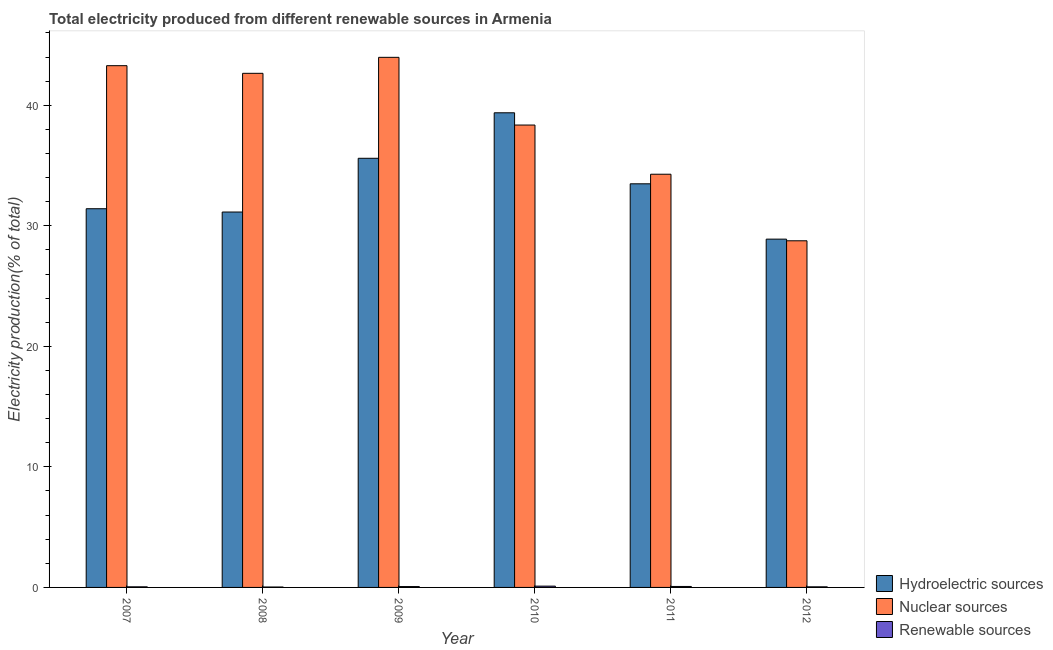How many groups of bars are there?
Ensure brevity in your answer.  6. Are the number of bars per tick equal to the number of legend labels?
Offer a terse response. Yes. What is the percentage of electricity produced by hydroelectric sources in 2011?
Your response must be concise. 33.49. Across all years, what is the maximum percentage of electricity produced by nuclear sources?
Keep it short and to the point. 43.98. Across all years, what is the minimum percentage of electricity produced by nuclear sources?
Offer a terse response. 28.76. What is the total percentage of electricity produced by nuclear sources in the graph?
Your answer should be very brief. 231.31. What is the difference between the percentage of electricity produced by hydroelectric sources in 2008 and that in 2009?
Your answer should be compact. -4.46. What is the difference between the percentage of electricity produced by nuclear sources in 2010 and the percentage of electricity produced by hydroelectric sources in 2008?
Offer a terse response. -4.29. What is the average percentage of electricity produced by nuclear sources per year?
Keep it short and to the point. 38.55. What is the ratio of the percentage of electricity produced by nuclear sources in 2010 to that in 2011?
Offer a terse response. 1.12. Is the difference between the percentage of electricity produced by hydroelectric sources in 2008 and 2011 greater than the difference between the percentage of electricity produced by renewable sources in 2008 and 2011?
Give a very brief answer. No. What is the difference between the highest and the second highest percentage of electricity produced by hydroelectric sources?
Give a very brief answer. 3.78. What is the difference between the highest and the lowest percentage of electricity produced by hydroelectric sources?
Offer a very short reply. 10.48. In how many years, is the percentage of electricity produced by nuclear sources greater than the average percentage of electricity produced by nuclear sources taken over all years?
Your response must be concise. 3. Is the sum of the percentage of electricity produced by hydroelectric sources in 2007 and 2011 greater than the maximum percentage of electricity produced by renewable sources across all years?
Give a very brief answer. Yes. What does the 3rd bar from the left in 2010 represents?
Keep it short and to the point. Renewable sources. What does the 2nd bar from the right in 2007 represents?
Provide a short and direct response. Nuclear sources. Is it the case that in every year, the sum of the percentage of electricity produced by hydroelectric sources and percentage of electricity produced by nuclear sources is greater than the percentage of electricity produced by renewable sources?
Keep it short and to the point. Yes. Are all the bars in the graph horizontal?
Your answer should be very brief. No. How many years are there in the graph?
Offer a terse response. 6. What is the difference between two consecutive major ticks on the Y-axis?
Offer a very short reply. 10. Does the graph contain grids?
Provide a succinct answer. No. Where does the legend appear in the graph?
Your response must be concise. Bottom right. How many legend labels are there?
Give a very brief answer. 3. What is the title of the graph?
Offer a terse response. Total electricity produced from different renewable sources in Armenia. What is the label or title of the Y-axis?
Provide a short and direct response. Electricity production(% of total). What is the Electricity production(% of total) in Hydroelectric sources in 2007?
Your response must be concise. 31.42. What is the Electricity production(% of total) in Nuclear sources in 2007?
Offer a terse response. 43.29. What is the Electricity production(% of total) of Renewable sources in 2007?
Provide a succinct answer. 0.05. What is the Electricity production(% of total) in Hydroelectric sources in 2008?
Make the answer very short. 31.14. What is the Electricity production(% of total) of Nuclear sources in 2008?
Ensure brevity in your answer.  42.65. What is the Electricity production(% of total) in Renewable sources in 2008?
Your response must be concise. 0.03. What is the Electricity production(% of total) of Hydroelectric sources in 2009?
Provide a short and direct response. 35.6. What is the Electricity production(% of total) in Nuclear sources in 2009?
Your answer should be very brief. 43.98. What is the Electricity production(% of total) in Renewable sources in 2009?
Offer a terse response. 0.07. What is the Electricity production(% of total) of Hydroelectric sources in 2010?
Offer a very short reply. 39.38. What is the Electricity production(% of total) in Nuclear sources in 2010?
Provide a short and direct response. 38.36. What is the Electricity production(% of total) in Renewable sources in 2010?
Your answer should be very brief. 0.11. What is the Electricity production(% of total) of Hydroelectric sources in 2011?
Your answer should be very brief. 33.49. What is the Electricity production(% of total) of Nuclear sources in 2011?
Provide a succinct answer. 34.28. What is the Electricity production(% of total) in Renewable sources in 2011?
Give a very brief answer. 0.08. What is the Electricity production(% of total) of Hydroelectric sources in 2012?
Keep it short and to the point. 28.89. What is the Electricity production(% of total) in Nuclear sources in 2012?
Provide a succinct answer. 28.76. What is the Electricity production(% of total) in Renewable sources in 2012?
Offer a very short reply. 0.05. Across all years, what is the maximum Electricity production(% of total) of Hydroelectric sources?
Ensure brevity in your answer.  39.38. Across all years, what is the maximum Electricity production(% of total) of Nuclear sources?
Keep it short and to the point. 43.98. Across all years, what is the maximum Electricity production(% of total) in Renewable sources?
Provide a short and direct response. 0.11. Across all years, what is the minimum Electricity production(% of total) of Hydroelectric sources?
Provide a succinct answer. 28.89. Across all years, what is the minimum Electricity production(% of total) in Nuclear sources?
Offer a very short reply. 28.76. Across all years, what is the minimum Electricity production(% of total) of Renewable sources?
Offer a very short reply. 0.03. What is the total Electricity production(% of total) of Hydroelectric sources in the graph?
Make the answer very short. 199.92. What is the total Electricity production(% of total) of Nuclear sources in the graph?
Provide a short and direct response. 231.31. What is the total Electricity production(% of total) in Renewable sources in the graph?
Provide a succinct answer. 0.39. What is the difference between the Electricity production(% of total) of Hydroelectric sources in 2007 and that in 2008?
Ensure brevity in your answer.  0.27. What is the difference between the Electricity production(% of total) in Nuclear sources in 2007 and that in 2008?
Provide a succinct answer. 0.63. What is the difference between the Electricity production(% of total) of Renewable sources in 2007 and that in 2008?
Make the answer very short. 0.02. What is the difference between the Electricity production(% of total) in Hydroelectric sources in 2007 and that in 2009?
Keep it short and to the point. -4.18. What is the difference between the Electricity production(% of total) of Nuclear sources in 2007 and that in 2009?
Provide a short and direct response. -0.69. What is the difference between the Electricity production(% of total) of Renewable sources in 2007 and that in 2009?
Give a very brief answer. -0.02. What is the difference between the Electricity production(% of total) in Hydroelectric sources in 2007 and that in 2010?
Your response must be concise. -7.96. What is the difference between the Electricity production(% of total) in Nuclear sources in 2007 and that in 2010?
Keep it short and to the point. 4.93. What is the difference between the Electricity production(% of total) of Renewable sources in 2007 and that in 2010?
Offer a terse response. -0.06. What is the difference between the Electricity production(% of total) of Hydroelectric sources in 2007 and that in 2011?
Offer a terse response. -2.07. What is the difference between the Electricity production(% of total) in Nuclear sources in 2007 and that in 2011?
Provide a short and direct response. 9.01. What is the difference between the Electricity production(% of total) in Renewable sources in 2007 and that in 2011?
Offer a very short reply. -0.03. What is the difference between the Electricity production(% of total) of Hydroelectric sources in 2007 and that in 2012?
Offer a very short reply. 2.52. What is the difference between the Electricity production(% of total) in Nuclear sources in 2007 and that in 2012?
Provide a succinct answer. 14.53. What is the difference between the Electricity production(% of total) in Renewable sources in 2007 and that in 2012?
Provide a succinct answer. 0. What is the difference between the Electricity production(% of total) of Hydroelectric sources in 2008 and that in 2009?
Make the answer very short. -4.46. What is the difference between the Electricity production(% of total) in Nuclear sources in 2008 and that in 2009?
Provide a succinct answer. -1.33. What is the difference between the Electricity production(% of total) of Renewable sources in 2008 and that in 2009?
Make the answer very short. -0.04. What is the difference between the Electricity production(% of total) of Hydroelectric sources in 2008 and that in 2010?
Make the answer very short. -8.23. What is the difference between the Electricity production(% of total) in Nuclear sources in 2008 and that in 2010?
Provide a short and direct response. 4.29. What is the difference between the Electricity production(% of total) of Renewable sources in 2008 and that in 2010?
Your response must be concise. -0.07. What is the difference between the Electricity production(% of total) of Hydroelectric sources in 2008 and that in 2011?
Your answer should be compact. -2.34. What is the difference between the Electricity production(% of total) of Nuclear sources in 2008 and that in 2011?
Ensure brevity in your answer.  8.37. What is the difference between the Electricity production(% of total) in Renewable sources in 2008 and that in 2011?
Ensure brevity in your answer.  -0.05. What is the difference between the Electricity production(% of total) of Hydroelectric sources in 2008 and that in 2012?
Your answer should be compact. 2.25. What is the difference between the Electricity production(% of total) in Nuclear sources in 2008 and that in 2012?
Provide a succinct answer. 13.89. What is the difference between the Electricity production(% of total) of Renewable sources in 2008 and that in 2012?
Provide a short and direct response. -0.02. What is the difference between the Electricity production(% of total) in Hydroelectric sources in 2009 and that in 2010?
Ensure brevity in your answer.  -3.78. What is the difference between the Electricity production(% of total) in Nuclear sources in 2009 and that in 2010?
Keep it short and to the point. 5.62. What is the difference between the Electricity production(% of total) in Renewable sources in 2009 and that in 2010?
Your answer should be very brief. -0.04. What is the difference between the Electricity production(% of total) in Hydroelectric sources in 2009 and that in 2011?
Your answer should be very brief. 2.12. What is the difference between the Electricity production(% of total) in Nuclear sources in 2009 and that in 2011?
Your answer should be compact. 9.7. What is the difference between the Electricity production(% of total) in Renewable sources in 2009 and that in 2011?
Ensure brevity in your answer.  -0.01. What is the difference between the Electricity production(% of total) of Hydroelectric sources in 2009 and that in 2012?
Offer a very short reply. 6.71. What is the difference between the Electricity production(% of total) of Nuclear sources in 2009 and that in 2012?
Make the answer very short. 15.22. What is the difference between the Electricity production(% of total) of Renewable sources in 2009 and that in 2012?
Make the answer very short. 0.02. What is the difference between the Electricity production(% of total) of Hydroelectric sources in 2010 and that in 2011?
Offer a terse response. 5.89. What is the difference between the Electricity production(% of total) of Nuclear sources in 2010 and that in 2011?
Your response must be concise. 4.08. What is the difference between the Electricity production(% of total) in Renewable sources in 2010 and that in 2011?
Give a very brief answer. 0.03. What is the difference between the Electricity production(% of total) in Hydroelectric sources in 2010 and that in 2012?
Make the answer very short. 10.48. What is the difference between the Electricity production(% of total) in Nuclear sources in 2010 and that in 2012?
Provide a short and direct response. 9.6. What is the difference between the Electricity production(% of total) in Renewable sources in 2010 and that in 2012?
Offer a very short reply. 0.06. What is the difference between the Electricity production(% of total) of Hydroelectric sources in 2011 and that in 2012?
Make the answer very short. 4.59. What is the difference between the Electricity production(% of total) in Nuclear sources in 2011 and that in 2012?
Offer a very short reply. 5.52. What is the difference between the Electricity production(% of total) of Renewable sources in 2011 and that in 2012?
Make the answer very short. 0.03. What is the difference between the Electricity production(% of total) in Hydroelectric sources in 2007 and the Electricity production(% of total) in Nuclear sources in 2008?
Offer a very short reply. -11.23. What is the difference between the Electricity production(% of total) in Hydroelectric sources in 2007 and the Electricity production(% of total) in Renewable sources in 2008?
Give a very brief answer. 31.38. What is the difference between the Electricity production(% of total) in Nuclear sources in 2007 and the Electricity production(% of total) in Renewable sources in 2008?
Your answer should be very brief. 43.25. What is the difference between the Electricity production(% of total) in Hydroelectric sources in 2007 and the Electricity production(% of total) in Nuclear sources in 2009?
Provide a succinct answer. -12.56. What is the difference between the Electricity production(% of total) of Hydroelectric sources in 2007 and the Electricity production(% of total) of Renewable sources in 2009?
Your response must be concise. 31.35. What is the difference between the Electricity production(% of total) of Nuclear sources in 2007 and the Electricity production(% of total) of Renewable sources in 2009?
Make the answer very short. 43.22. What is the difference between the Electricity production(% of total) in Hydroelectric sources in 2007 and the Electricity production(% of total) in Nuclear sources in 2010?
Your answer should be compact. -6.94. What is the difference between the Electricity production(% of total) of Hydroelectric sources in 2007 and the Electricity production(% of total) of Renewable sources in 2010?
Your answer should be very brief. 31.31. What is the difference between the Electricity production(% of total) of Nuclear sources in 2007 and the Electricity production(% of total) of Renewable sources in 2010?
Your response must be concise. 43.18. What is the difference between the Electricity production(% of total) in Hydroelectric sources in 2007 and the Electricity production(% of total) in Nuclear sources in 2011?
Ensure brevity in your answer.  -2.86. What is the difference between the Electricity production(% of total) in Hydroelectric sources in 2007 and the Electricity production(% of total) in Renewable sources in 2011?
Your answer should be compact. 31.34. What is the difference between the Electricity production(% of total) of Nuclear sources in 2007 and the Electricity production(% of total) of Renewable sources in 2011?
Offer a very short reply. 43.21. What is the difference between the Electricity production(% of total) in Hydroelectric sources in 2007 and the Electricity production(% of total) in Nuclear sources in 2012?
Give a very brief answer. 2.66. What is the difference between the Electricity production(% of total) of Hydroelectric sources in 2007 and the Electricity production(% of total) of Renewable sources in 2012?
Your response must be concise. 31.37. What is the difference between the Electricity production(% of total) in Nuclear sources in 2007 and the Electricity production(% of total) in Renewable sources in 2012?
Provide a succinct answer. 43.24. What is the difference between the Electricity production(% of total) in Hydroelectric sources in 2008 and the Electricity production(% of total) in Nuclear sources in 2009?
Give a very brief answer. -12.83. What is the difference between the Electricity production(% of total) of Hydroelectric sources in 2008 and the Electricity production(% of total) of Renewable sources in 2009?
Provide a short and direct response. 31.07. What is the difference between the Electricity production(% of total) in Nuclear sources in 2008 and the Electricity production(% of total) in Renewable sources in 2009?
Provide a short and direct response. 42.58. What is the difference between the Electricity production(% of total) of Hydroelectric sources in 2008 and the Electricity production(% of total) of Nuclear sources in 2010?
Provide a succinct answer. -7.22. What is the difference between the Electricity production(% of total) in Hydroelectric sources in 2008 and the Electricity production(% of total) in Renewable sources in 2010?
Make the answer very short. 31.04. What is the difference between the Electricity production(% of total) of Nuclear sources in 2008 and the Electricity production(% of total) of Renewable sources in 2010?
Offer a terse response. 42.54. What is the difference between the Electricity production(% of total) in Hydroelectric sources in 2008 and the Electricity production(% of total) in Nuclear sources in 2011?
Keep it short and to the point. -3.14. What is the difference between the Electricity production(% of total) in Hydroelectric sources in 2008 and the Electricity production(% of total) in Renewable sources in 2011?
Make the answer very short. 31.06. What is the difference between the Electricity production(% of total) of Nuclear sources in 2008 and the Electricity production(% of total) of Renewable sources in 2011?
Provide a succinct answer. 42.57. What is the difference between the Electricity production(% of total) in Hydroelectric sources in 2008 and the Electricity production(% of total) in Nuclear sources in 2012?
Make the answer very short. 2.39. What is the difference between the Electricity production(% of total) of Hydroelectric sources in 2008 and the Electricity production(% of total) of Renewable sources in 2012?
Keep it short and to the point. 31.09. What is the difference between the Electricity production(% of total) in Nuclear sources in 2008 and the Electricity production(% of total) in Renewable sources in 2012?
Provide a succinct answer. 42.6. What is the difference between the Electricity production(% of total) of Hydroelectric sources in 2009 and the Electricity production(% of total) of Nuclear sources in 2010?
Your answer should be very brief. -2.76. What is the difference between the Electricity production(% of total) of Hydroelectric sources in 2009 and the Electricity production(% of total) of Renewable sources in 2010?
Offer a very short reply. 35.49. What is the difference between the Electricity production(% of total) of Nuclear sources in 2009 and the Electricity production(% of total) of Renewable sources in 2010?
Offer a very short reply. 43.87. What is the difference between the Electricity production(% of total) of Hydroelectric sources in 2009 and the Electricity production(% of total) of Nuclear sources in 2011?
Offer a very short reply. 1.32. What is the difference between the Electricity production(% of total) in Hydroelectric sources in 2009 and the Electricity production(% of total) in Renewable sources in 2011?
Your answer should be very brief. 35.52. What is the difference between the Electricity production(% of total) of Nuclear sources in 2009 and the Electricity production(% of total) of Renewable sources in 2011?
Provide a short and direct response. 43.9. What is the difference between the Electricity production(% of total) of Hydroelectric sources in 2009 and the Electricity production(% of total) of Nuclear sources in 2012?
Ensure brevity in your answer.  6.84. What is the difference between the Electricity production(% of total) in Hydroelectric sources in 2009 and the Electricity production(% of total) in Renewable sources in 2012?
Your response must be concise. 35.55. What is the difference between the Electricity production(% of total) of Nuclear sources in 2009 and the Electricity production(% of total) of Renewable sources in 2012?
Make the answer very short. 43.93. What is the difference between the Electricity production(% of total) in Hydroelectric sources in 2010 and the Electricity production(% of total) in Nuclear sources in 2011?
Ensure brevity in your answer.  5.1. What is the difference between the Electricity production(% of total) in Hydroelectric sources in 2010 and the Electricity production(% of total) in Renewable sources in 2011?
Your response must be concise. 39.3. What is the difference between the Electricity production(% of total) of Nuclear sources in 2010 and the Electricity production(% of total) of Renewable sources in 2011?
Offer a very short reply. 38.28. What is the difference between the Electricity production(% of total) of Hydroelectric sources in 2010 and the Electricity production(% of total) of Nuclear sources in 2012?
Provide a succinct answer. 10.62. What is the difference between the Electricity production(% of total) of Hydroelectric sources in 2010 and the Electricity production(% of total) of Renewable sources in 2012?
Your response must be concise. 39.33. What is the difference between the Electricity production(% of total) in Nuclear sources in 2010 and the Electricity production(% of total) in Renewable sources in 2012?
Offer a terse response. 38.31. What is the difference between the Electricity production(% of total) of Hydroelectric sources in 2011 and the Electricity production(% of total) of Nuclear sources in 2012?
Give a very brief answer. 4.73. What is the difference between the Electricity production(% of total) of Hydroelectric sources in 2011 and the Electricity production(% of total) of Renewable sources in 2012?
Offer a terse response. 33.44. What is the difference between the Electricity production(% of total) in Nuclear sources in 2011 and the Electricity production(% of total) in Renewable sources in 2012?
Offer a very short reply. 34.23. What is the average Electricity production(% of total) in Hydroelectric sources per year?
Make the answer very short. 33.32. What is the average Electricity production(% of total) in Nuclear sources per year?
Offer a very short reply. 38.55. What is the average Electricity production(% of total) of Renewable sources per year?
Your answer should be compact. 0.07. In the year 2007, what is the difference between the Electricity production(% of total) of Hydroelectric sources and Electricity production(% of total) of Nuclear sources?
Make the answer very short. -11.87. In the year 2007, what is the difference between the Electricity production(% of total) in Hydroelectric sources and Electricity production(% of total) in Renewable sources?
Offer a terse response. 31.37. In the year 2007, what is the difference between the Electricity production(% of total) in Nuclear sources and Electricity production(% of total) in Renewable sources?
Make the answer very short. 43.23. In the year 2008, what is the difference between the Electricity production(% of total) in Hydroelectric sources and Electricity production(% of total) in Nuclear sources?
Make the answer very short. -11.51. In the year 2008, what is the difference between the Electricity production(% of total) of Hydroelectric sources and Electricity production(% of total) of Renewable sources?
Give a very brief answer. 31.11. In the year 2008, what is the difference between the Electricity production(% of total) of Nuclear sources and Electricity production(% of total) of Renewable sources?
Ensure brevity in your answer.  42.62. In the year 2009, what is the difference between the Electricity production(% of total) of Hydroelectric sources and Electricity production(% of total) of Nuclear sources?
Ensure brevity in your answer.  -8.38. In the year 2009, what is the difference between the Electricity production(% of total) of Hydroelectric sources and Electricity production(% of total) of Renewable sources?
Make the answer very short. 35.53. In the year 2009, what is the difference between the Electricity production(% of total) of Nuclear sources and Electricity production(% of total) of Renewable sources?
Your answer should be compact. 43.91. In the year 2010, what is the difference between the Electricity production(% of total) in Hydroelectric sources and Electricity production(% of total) in Nuclear sources?
Keep it short and to the point. 1.02. In the year 2010, what is the difference between the Electricity production(% of total) in Hydroelectric sources and Electricity production(% of total) in Renewable sources?
Ensure brevity in your answer.  39.27. In the year 2010, what is the difference between the Electricity production(% of total) in Nuclear sources and Electricity production(% of total) in Renewable sources?
Make the answer very short. 38.25. In the year 2011, what is the difference between the Electricity production(% of total) in Hydroelectric sources and Electricity production(% of total) in Nuclear sources?
Your answer should be compact. -0.79. In the year 2011, what is the difference between the Electricity production(% of total) of Hydroelectric sources and Electricity production(% of total) of Renewable sources?
Offer a terse response. 33.41. In the year 2011, what is the difference between the Electricity production(% of total) of Nuclear sources and Electricity production(% of total) of Renewable sources?
Your response must be concise. 34.2. In the year 2012, what is the difference between the Electricity production(% of total) in Hydroelectric sources and Electricity production(% of total) in Nuclear sources?
Offer a very short reply. 0.14. In the year 2012, what is the difference between the Electricity production(% of total) of Hydroelectric sources and Electricity production(% of total) of Renewable sources?
Keep it short and to the point. 28.85. In the year 2012, what is the difference between the Electricity production(% of total) in Nuclear sources and Electricity production(% of total) in Renewable sources?
Ensure brevity in your answer.  28.71. What is the ratio of the Electricity production(% of total) of Hydroelectric sources in 2007 to that in 2008?
Ensure brevity in your answer.  1.01. What is the ratio of the Electricity production(% of total) in Nuclear sources in 2007 to that in 2008?
Provide a short and direct response. 1.01. What is the ratio of the Electricity production(% of total) in Renewable sources in 2007 to that in 2008?
Your answer should be compact. 1.47. What is the ratio of the Electricity production(% of total) of Hydroelectric sources in 2007 to that in 2009?
Your answer should be compact. 0.88. What is the ratio of the Electricity production(% of total) in Nuclear sources in 2007 to that in 2009?
Give a very brief answer. 0.98. What is the ratio of the Electricity production(% of total) in Renewable sources in 2007 to that in 2009?
Your answer should be very brief. 0.72. What is the ratio of the Electricity production(% of total) in Hydroelectric sources in 2007 to that in 2010?
Provide a short and direct response. 0.8. What is the ratio of the Electricity production(% of total) of Nuclear sources in 2007 to that in 2010?
Provide a short and direct response. 1.13. What is the ratio of the Electricity production(% of total) of Renewable sources in 2007 to that in 2010?
Keep it short and to the point. 0.47. What is the ratio of the Electricity production(% of total) of Hydroelectric sources in 2007 to that in 2011?
Give a very brief answer. 0.94. What is the ratio of the Electricity production(% of total) of Nuclear sources in 2007 to that in 2011?
Keep it short and to the point. 1.26. What is the ratio of the Electricity production(% of total) in Renewable sources in 2007 to that in 2011?
Offer a very short reply. 0.63. What is the ratio of the Electricity production(% of total) of Hydroelectric sources in 2007 to that in 2012?
Provide a succinct answer. 1.09. What is the ratio of the Electricity production(% of total) of Nuclear sources in 2007 to that in 2012?
Your answer should be compact. 1.51. What is the ratio of the Electricity production(% of total) in Renewable sources in 2007 to that in 2012?
Provide a short and direct response. 1.02. What is the ratio of the Electricity production(% of total) in Hydroelectric sources in 2008 to that in 2009?
Make the answer very short. 0.87. What is the ratio of the Electricity production(% of total) of Nuclear sources in 2008 to that in 2009?
Your answer should be very brief. 0.97. What is the ratio of the Electricity production(% of total) of Renewable sources in 2008 to that in 2009?
Offer a very short reply. 0.49. What is the ratio of the Electricity production(% of total) of Hydroelectric sources in 2008 to that in 2010?
Your response must be concise. 0.79. What is the ratio of the Electricity production(% of total) of Nuclear sources in 2008 to that in 2010?
Your answer should be very brief. 1.11. What is the ratio of the Electricity production(% of total) in Renewable sources in 2008 to that in 2010?
Make the answer very short. 0.32. What is the ratio of the Electricity production(% of total) of Hydroelectric sources in 2008 to that in 2011?
Make the answer very short. 0.93. What is the ratio of the Electricity production(% of total) of Nuclear sources in 2008 to that in 2011?
Your answer should be compact. 1.24. What is the ratio of the Electricity production(% of total) in Renewable sources in 2008 to that in 2011?
Provide a succinct answer. 0.43. What is the ratio of the Electricity production(% of total) in Hydroelectric sources in 2008 to that in 2012?
Give a very brief answer. 1.08. What is the ratio of the Electricity production(% of total) in Nuclear sources in 2008 to that in 2012?
Keep it short and to the point. 1.48. What is the ratio of the Electricity production(% of total) of Renewable sources in 2008 to that in 2012?
Ensure brevity in your answer.  0.7. What is the ratio of the Electricity production(% of total) in Hydroelectric sources in 2009 to that in 2010?
Provide a short and direct response. 0.9. What is the ratio of the Electricity production(% of total) of Nuclear sources in 2009 to that in 2010?
Your answer should be compact. 1.15. What is the ratio of the Electricity production(% of total) of Renewable sources in 2009 to that in 2010?
Offer a terse response. 0.65. What is the ratio of the Electricity production(% of total) of Hydroelectric sources in 2009 to that in 2011?
Provide a succinct answer. 1.06. What is the ratio of the Electricity production(% of total) of Nuclear sources in 2009 to that in 2011?
Your response must be concise. 1.28. What is the ratio of the Electricity production(% of total) in Renewable sources in 2009 to that in 2011?
Ensure brevity in your answer.  0.87. What is the ratio of the Electricity production(% of total) in Hydroelectric sources in 2009 to that in 2012?
Provide a short and direct response. 1.23. What is the ratio of the Electricity production(% of total) of Nuclear sources in 2009 to that in 2012?
Ensure brevity in your answer.  1.53. What is the ratio of the Electricity production(% of total) in Renewable sources in 2009 to that in 2012?
Provide a succinct answer. 1.42. What is the ratio of the Electricity production(% of total) in Hydroelectric sources in 2010 to that in 2011?
Your answer should be very brief. 1.18. What is the ratio of the Electricity production(% of total) in Nuclear sources in 2010 to that in 2011?
Offer a very short reply. 1.12. What is the ratio of the Electricity production(% of total) of Renewable sources in 2010 to that in 2011?
Make the answer very short. 1.34. What is the ratio of the Electricity production(% of total) of Hydroelectric sources in 2010 to that in 2012?
Make the answer very short. 1.36. What is the ratio of the Electricity production(% of total) in Nuclear sources in 2010 to that in 2012?
Ensure brevity in your answer.  1.33. What is the ratio of the Electricity production(% of total) in Renewable sources in 2010 to that in 2012?
Provide a short and direct response. 2.17. What is the ratio of the Electricity production(% of total) in Hydroelectric sources in 2011 to that in 2012?
Offer a terse response. 1.16. What is the ratio of the Electricity production(% of total) in Nuclear sources in 2011 to that in 2012?
Offer a terse response. 1.19. What is the ratio of the Electricity production(% of total) of Renewable sources in 2011 to that in 2012?
Provide a succinct answer. 1.62. What is the difference between the highest and the second highest Electricity production(% of total) of Hydroelectric sources?
Make the answer very short. 3.78. What is the difference between the highest and the second highest Electricity production(% of total) of Nuclear sources?
Ensure brevity in your answer.  0.69. What is the difference between the highest and the second highest Electricity production(% of total) in Renewable sources?
Offer a very short reply. 0.03. What is the difference between the highest and the lowest Electricity production(% of total) of Hydroelectric sources?
Offer a very short reply. 10.48. What is the difference between the highest and the lowest Electricity production(% of total) of Nuclear sources?
Provide a succinct answer. 15.22. What is the difference between the highest and the lowest Electricity production(% of total) of Renewable sources?
Your answer should be very brief. 0.07. 